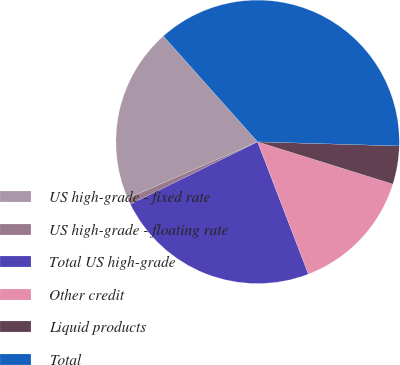<chart> <loc_0><loc_0><loc_500><loc_500><pie_chart><fcel>US high-grade - fixed rate<fcel>US high-grade - floating rate<fcel>Total US high-grade<fcel>Other credit<fcel>Liquid products<fcel>Total<nl><fcel>19.94%<fcel>0.73%<fcel>23.57%<fcel>14.34%<fcel>4.36%<fcel>37.04%<nl></chart> 